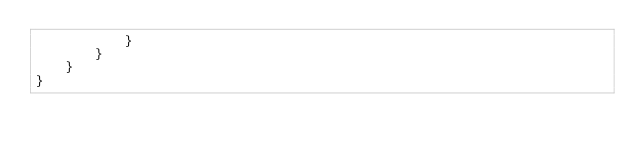<code> <loc_0><loc_0><loc_500><loc_500><_Rust_>            }
        }
    }
}
</code> 